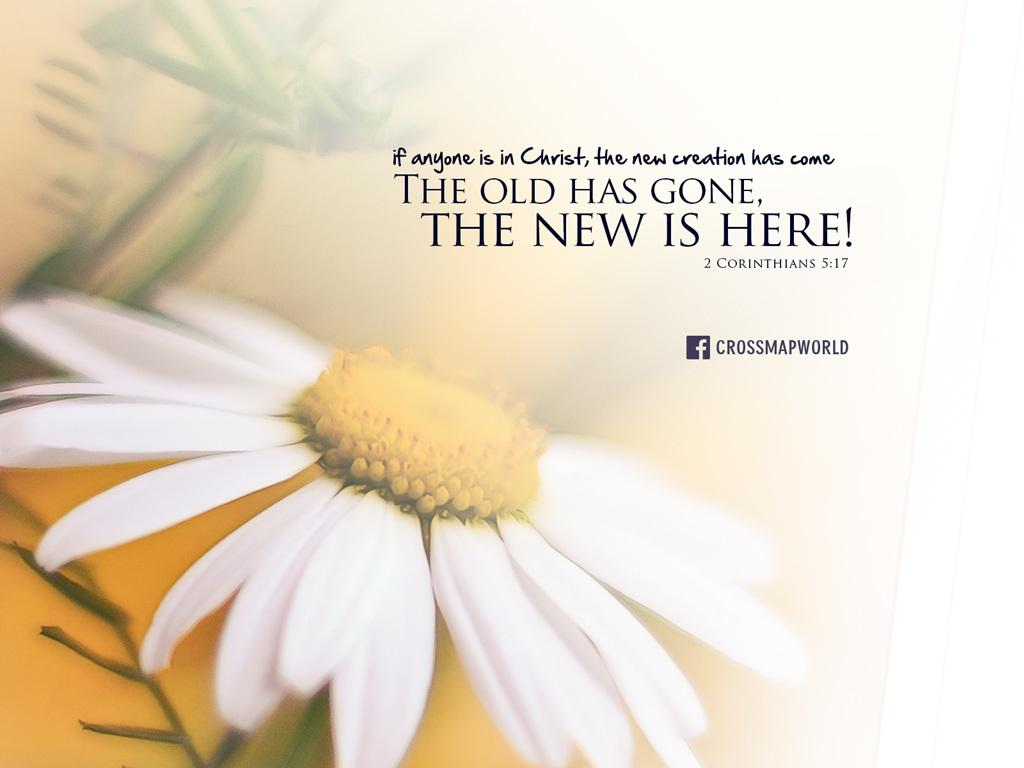What is present on the poster in the image? There is a poster in the image, and it has some text on it. What else can be seen on the poster besides the text? There is a white-colored flower on the poster. What type of sweater is the visitor wearing in the image? There is no visitor or sweater present in the image; it only features a poster with text and a white-colored flower. 